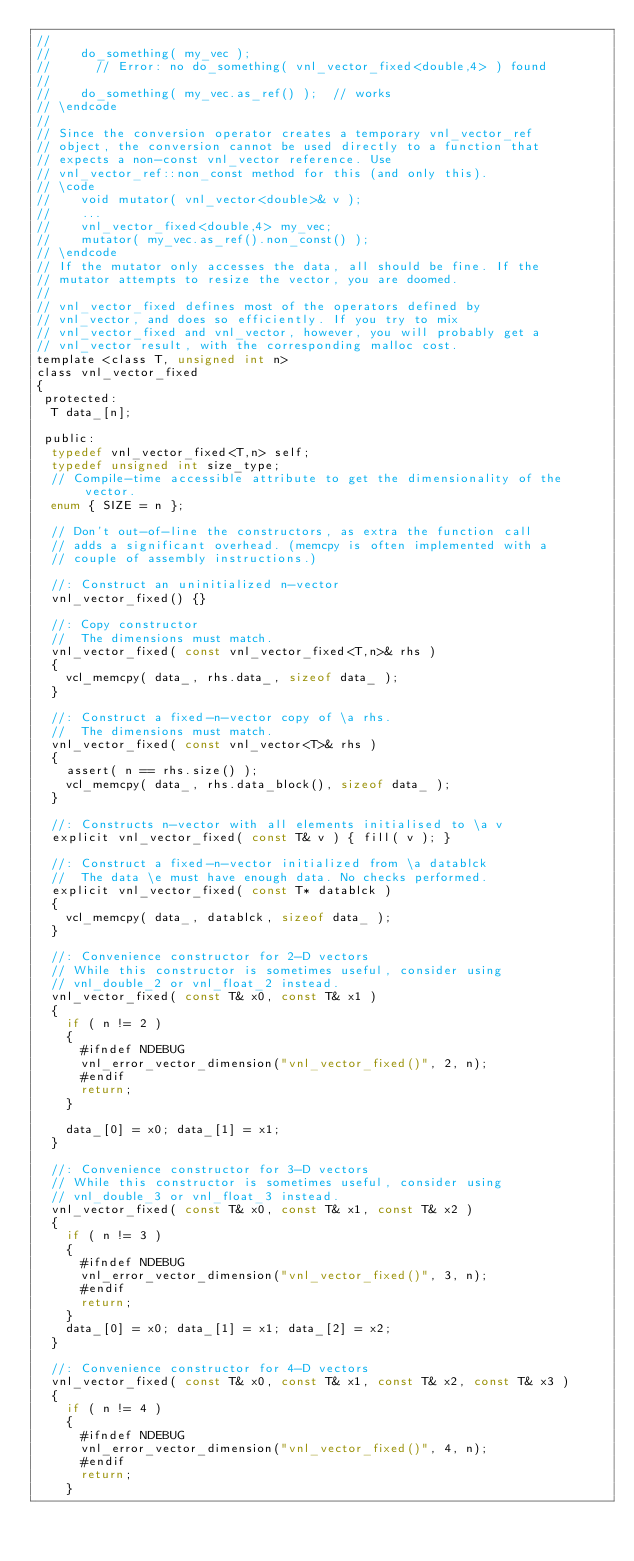Convert code to text. <code><loc_0><loc_0><loc_500><loc_500><_C_>//
//    do_something( my_vec );
//      // Error: no do_something( vnl_vector_fixed<double,4> ) found
//
//    do_something( my_vec.as_ref() );  // works
// \endcode
//
// Since the conversion operator creates a temporary vnl_vector_ref
// object, the conversion cannot be used directly to a function that
// expects a non-const vnl_vector reference. Use
// vnl_vector_ref::non_const method for this (and only this).
// \code
//    void mutator( vnl_vector<double>& v );
//    ...
//    vnl_vector_fixed<double,4> my_vec;
//    mutator( my_vec.as_ref().non_const() );
// \endcode
// If the mutator only accesses the data, all should be fine. If the
// mutator attempts to resize the vector, you are doomed.
//
// vnl_vector_fixed defines most of the operators defined by
// vnl_vector, and does so efficiently. If you try to mix
// vnl_vector_fixed and vnl_vector, however, you will probably get a
// vnl_vector result, with the corresponding malloc cost.
template <class T, unsigned int n>
class vnl_vector_fixed
{
 protected:
  T data_[n];

 public:
  typedef vnl_vector_fixed<T,n> self;
  typedef unsigned int size_type;
  // Compile-time accessible attribute to get the dimensionality of the vector.
  enum { SIZE = n };

  // Don't out-of-line the constructors, as extra the function call
  // adds a significant overhead. (memcpy is often implemented with a
  // couple of assembly instructions.)

  //: Construct an uninitialized n-vector
  vnl_vector_fixed() {}

  //: Copy constructor
  //  The dimensions must match.
  vnl_vector_fixed( const vnl_vector_fixed<T,n>& rhs )
  {
    vcl_memcpy( data_, rhs.data_, sizeof data_ );
  }

  //: Construct a fixed-n-vector copy of \a rhs.
  //  The dimensions must match.
  vnl_vector_fixed( const vnl_vector<T>& rhs )
  {
    assert( n == rhs.size() );
    vcl_memcpy( data_, rhs.data_block(), sizeof data_ );
  }

  //: Constructs n-vector with all elements initialised to \a v
  explicit vnl_vector_fixed( const T& v ) { fill( v ); }

  //: Construct a fixed-n-vector initialized from \a datablck
  //  The data \e must have enough data. No checks performed.
  explicit vnl_vector_fixed( const T* datablck )
  {
    vcl_memcpy( data_, datablck, sizeof data_ );
  }

  //: Convenience constructor for 2-D vectors
  // While this constructor is sometimes useful, consider using
  // vnl_double_2 or vnl_float_2 instead.
  vnl_vector_fixed( const T& x0, const T& x1 )
  {
    if ( n != 2 )
    {
      #ifndef NDEBUG
      vnl_error_vector_dimension("vnl_vector_fixed()", 2, n);
      #endif
      return;
    }

    data_[0] = x0; data_[1] = x1;
  }

  //: Convenience constructor for 3-D vectors
  // While this constructor is sometimes useful, consider using
  // vnl_double_3 or vnl_float_3 instead.
  vnl_vector_fixed( const T& x0, const T& x1, const T& x2 )
  {
    if ( n != 3 )
    {
      #ifndef NDEBUG
      vnl_error_vector_dimension("vnl_vector_fixed()", 3, n);
      #endif
      return;
    }
    data_[0] = x0; data_[1] = x1; data_[2] = x2;
  }

  //: Convenience constructor for 4-D vectors
  vnl_vector_fixed( const T& x0, const T& x1, const T& x2, const T& x3 )
  {
    if ( n != 4 )
    {
      #ifndef NDEBUG
      vnl_error_vector_dimension("vnl_vector_fixed()", 4, n);
      #endif
      return;
    }</code> 